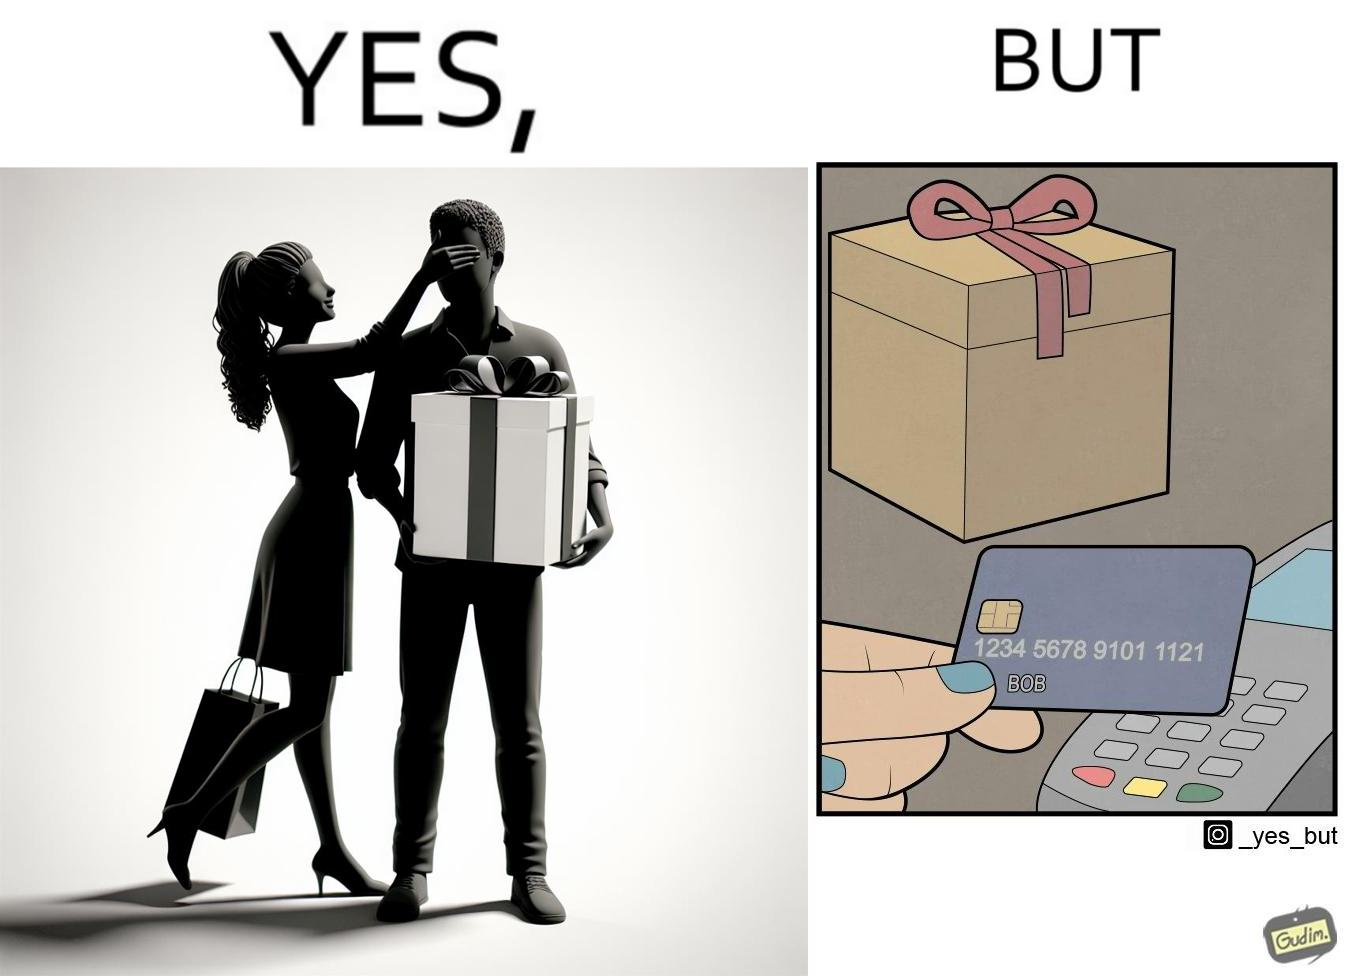What is the satirical meaning behind this image? The image is ironical, as a woman is gifting something to a person named Bob, while using Bob's card itself to purchase the gift. 